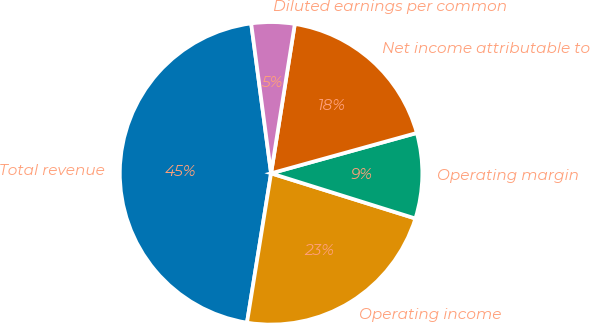<chart> <loc_0><loc_0><loc_500><loc_500><pie_chart><fcel>Total revenue<fcel>Operating income<fcel>Operating margin<fcel>Net income attributable to<fcel>Diluted earnings per common<nl><fcel>45.36%<fcel>22.72%<fcel>9.13%<fcel>18.19%<fcel>4.61%<nl></chart> 